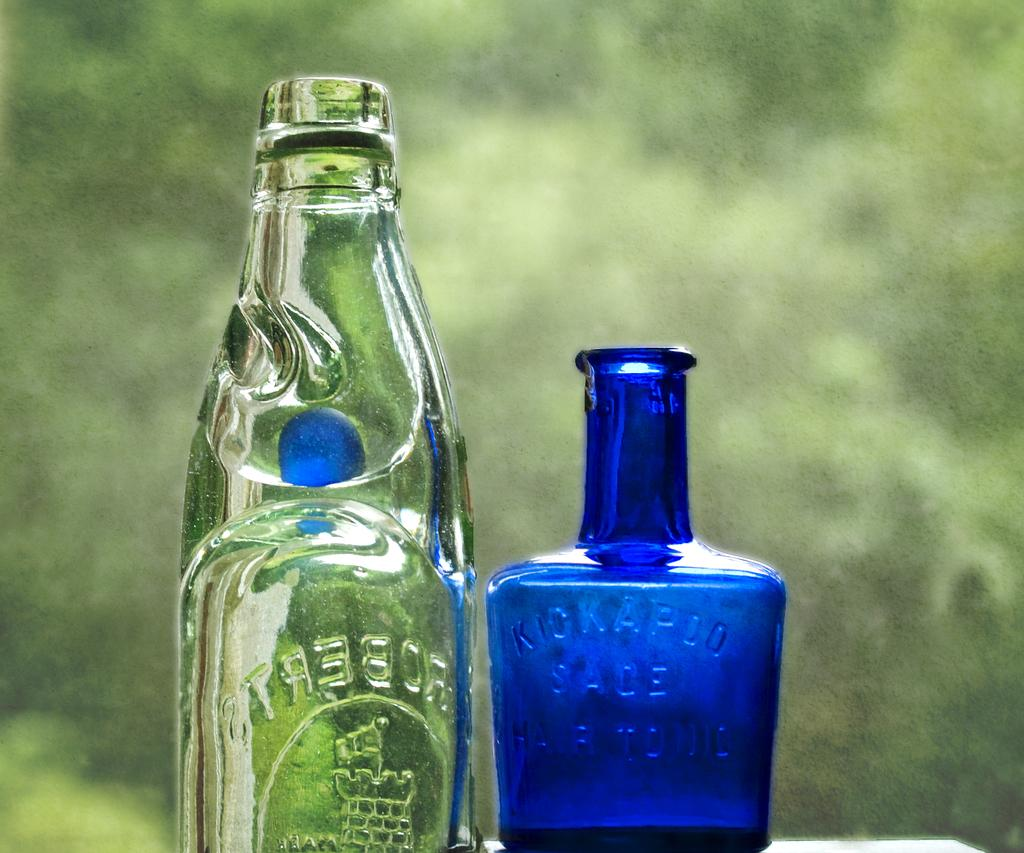<image>
Render a clear and concise summary of the photo. A blue Kickapoo bottle stands next to a clear, taller bottle. 